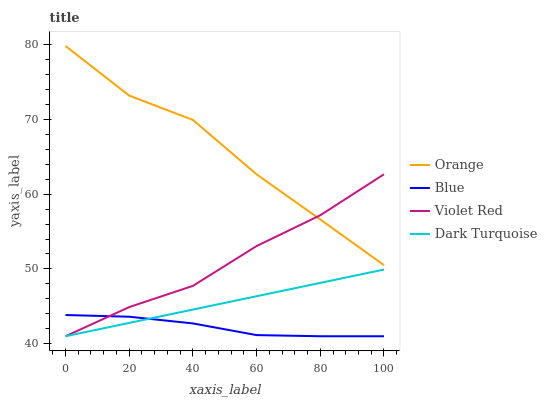Does Blue have the minimum area under the curve?
Answer yes or no. Yes. Does Orange have the maximum area under the curve?
Answer yes or no. Yes. Does Violet Red have the minimum area under the curve?
Answer yes or no. No. Does Violet Red have the maximum area under the curve?
Answer yes or no. No. Is Dark Turquoise the smoothest?
Answer yes or no. Yes. Is Orange the roughest?
Answer yes or no. Yes. Is Blue the smoothest?
Answer yes or no. No. Is Blue the roughest?
Answer yes or no. No. Does Blue have the lowest value?
Answer yes or no. Yes. Does Orange have the highest value?
Answer yes or no. Yes. Does Violet Red have the highest value?
Answer yes or no. No. Is Dark Turquoise less than Orange?
Answer yes or no. Yes. Is Orange greater than Blue?
Answer yes or no. Yes. Does Orange intersect Violet Red?
Answer yes or no. Yes. Is Orange less than Violet Red?
Answer yes or no. No. Is Orange greater than Violet Red?
Answer yes or no. No. Does Dark Turquoise intersect Orange?
Answer yes or no. No. 